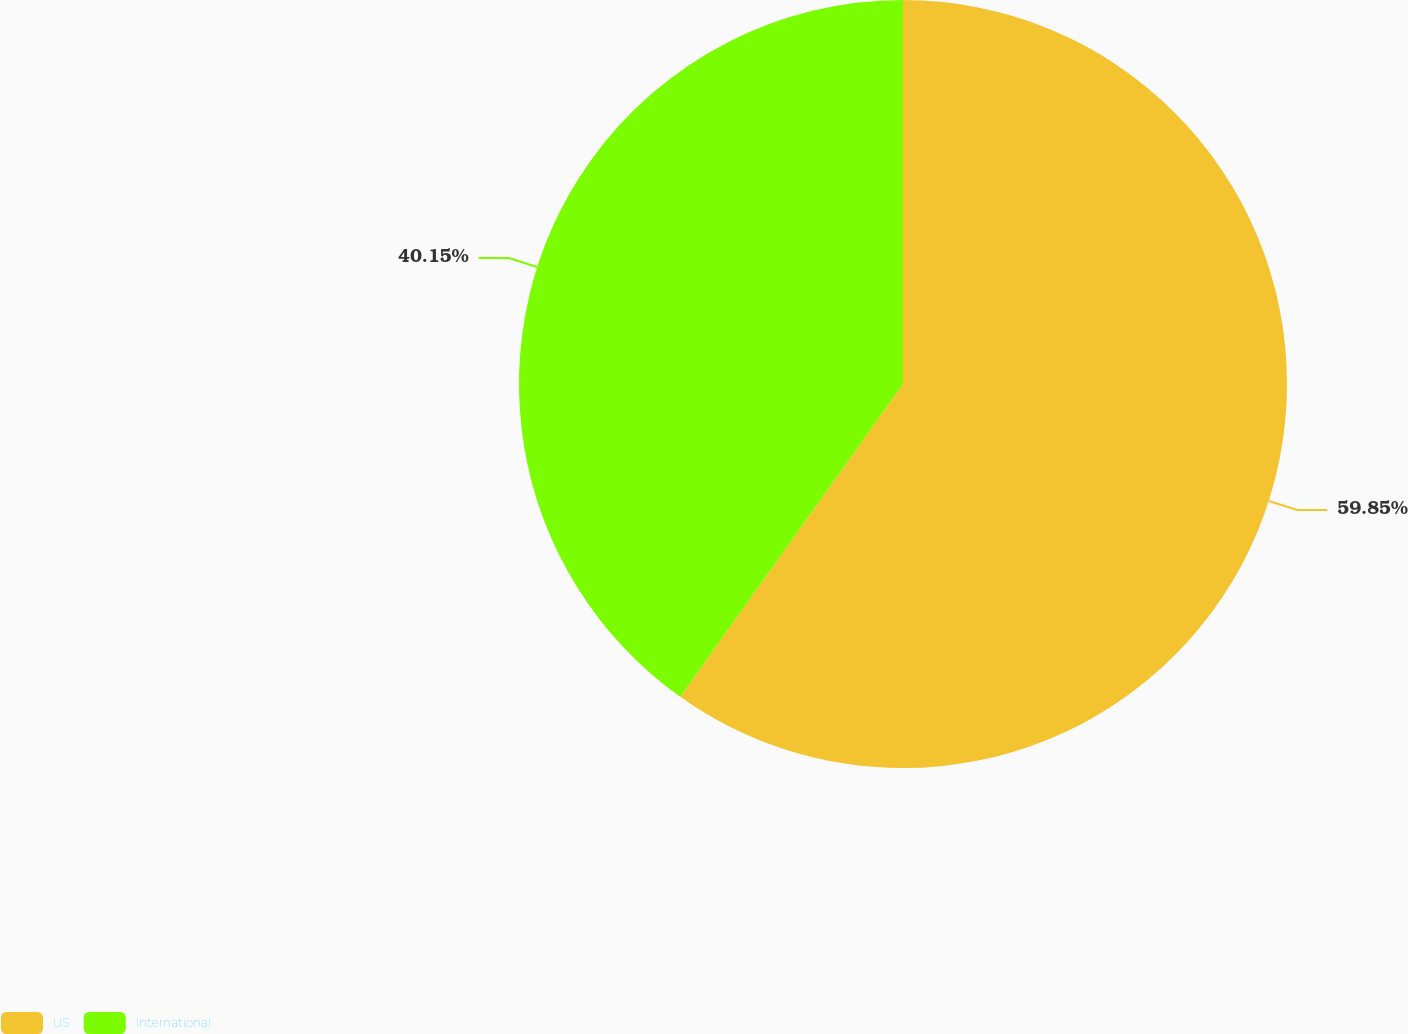Convert chart to OTSL. <chart><loc_0><loc_0><loc_500><loc_500><pie_chart><fcel>US<fcel>International<nl><fcel>59.85%<fcel>40.15%<nl></chart> 